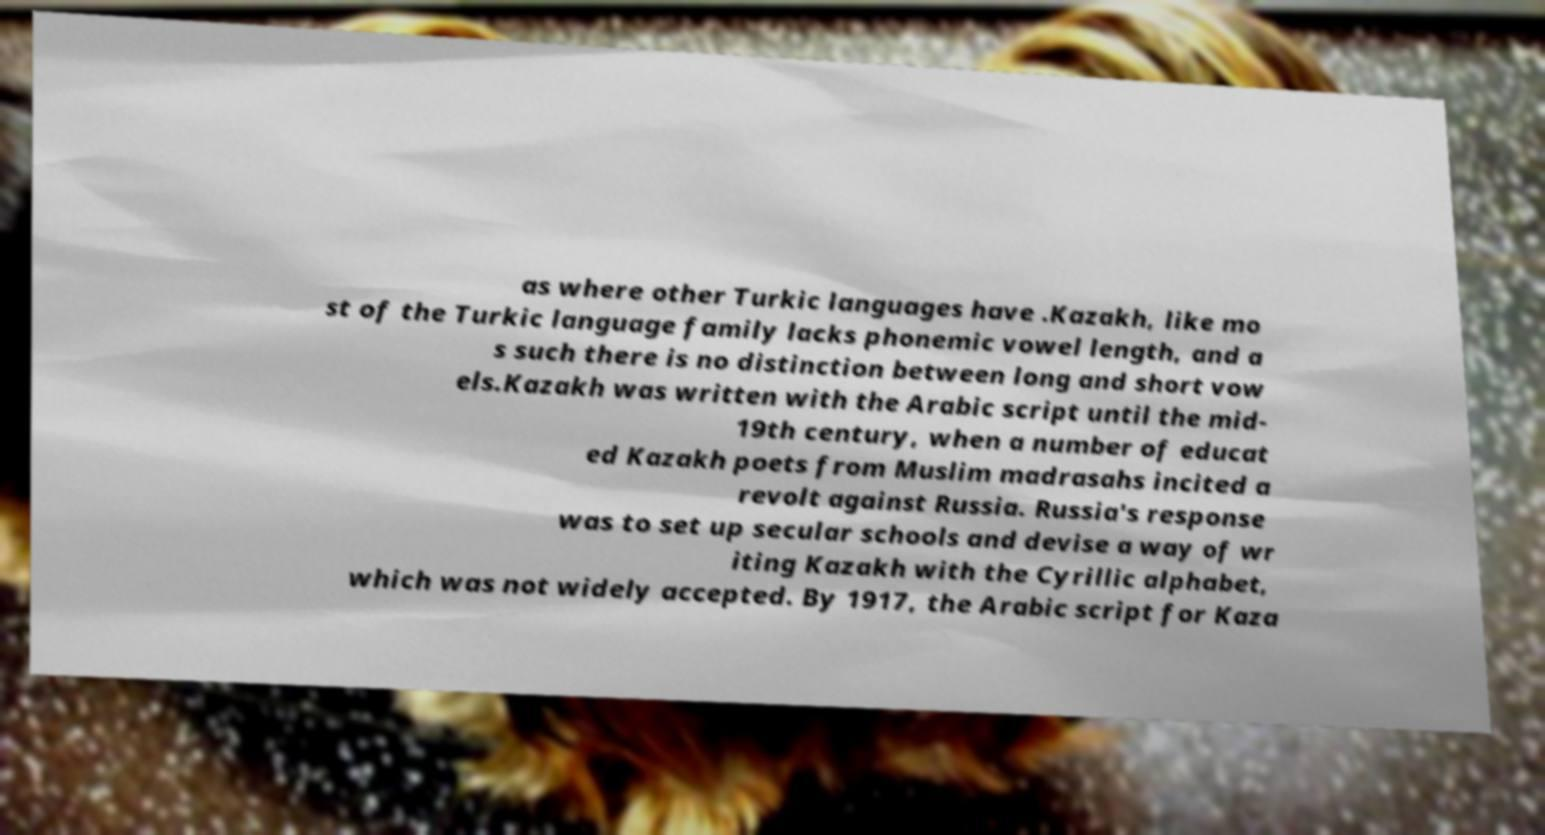What messages or text are displayed in this image? I need them in a readable, typed format. as where other Turkic languages have .Kazakh, like mo st of the Turkic language family lacks phonemic vowel length, and a s such there is no distinction between long and short vow els.Kazakh was written with the Arabic script until the mid- 19th century, when a number of educat ed Kazakh poets from Muslim madrasahs incited a revolt against Russia. Russia's response was to set up secular schools and devise a way of wr iting Kazakh with the Cyrillic alphabet, which was not widely accepted. By 1917, the Arabic script for Kaza 